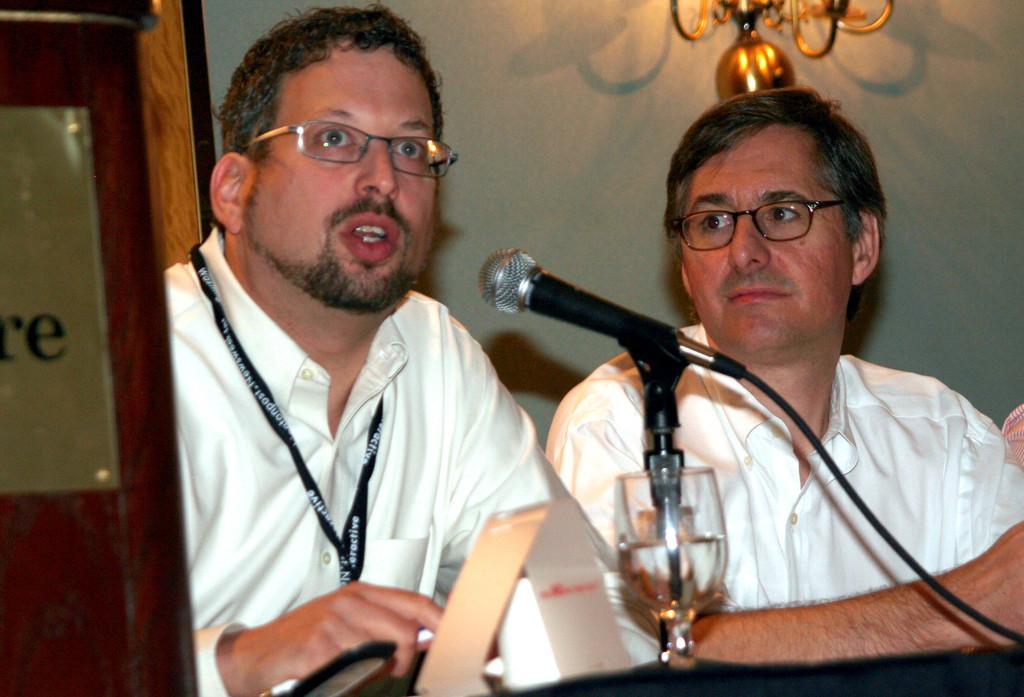Could you give a brief overview of what you see in this image? In the middle of the picture we can see two persons. In the foreground we can see mic, cable, stand, glass, table and other objects. On the left there is a board, on the board there is text. In the background we can see wall and another object. 